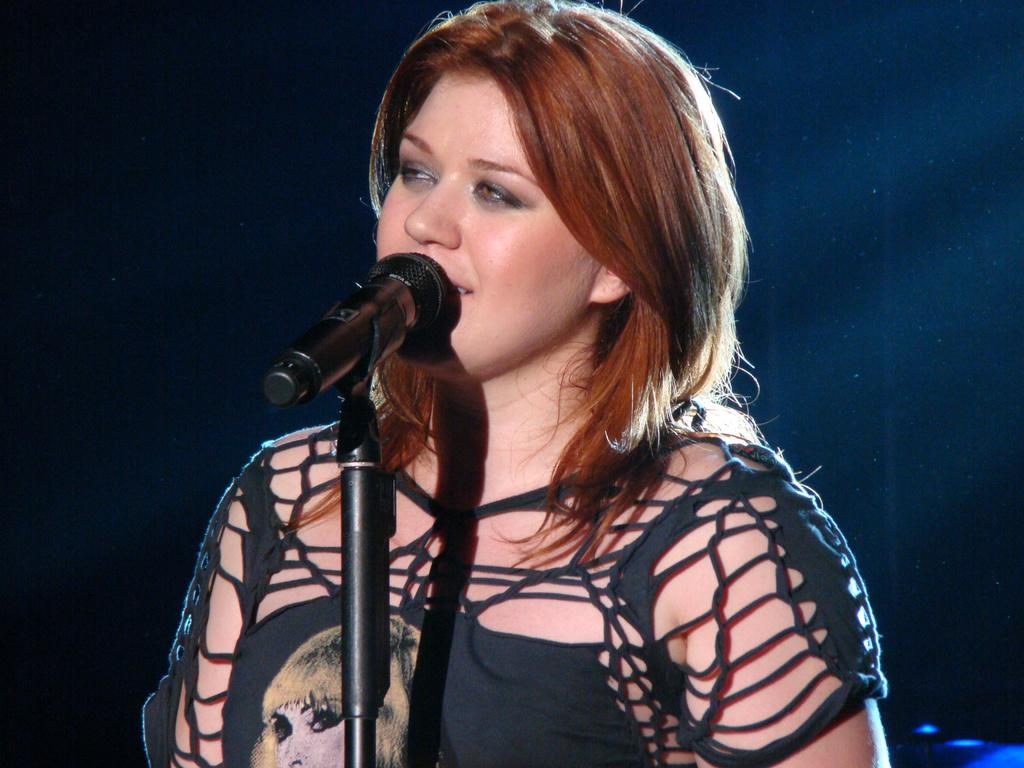What is the color of the background in the image? The background of the image is dark. Who or what is located in the middle of the image? There is a girl in the middle of the image. What object can be seen in the image? There is a microphone in the image. What type of nose can be seen on the girl in the image? There is no specific type of nose visible on the girl in the image; we can only see her face in general. What musical note is being played by the girl in the image? There is no indication in the image that the girl is playing any musical notes. --- 